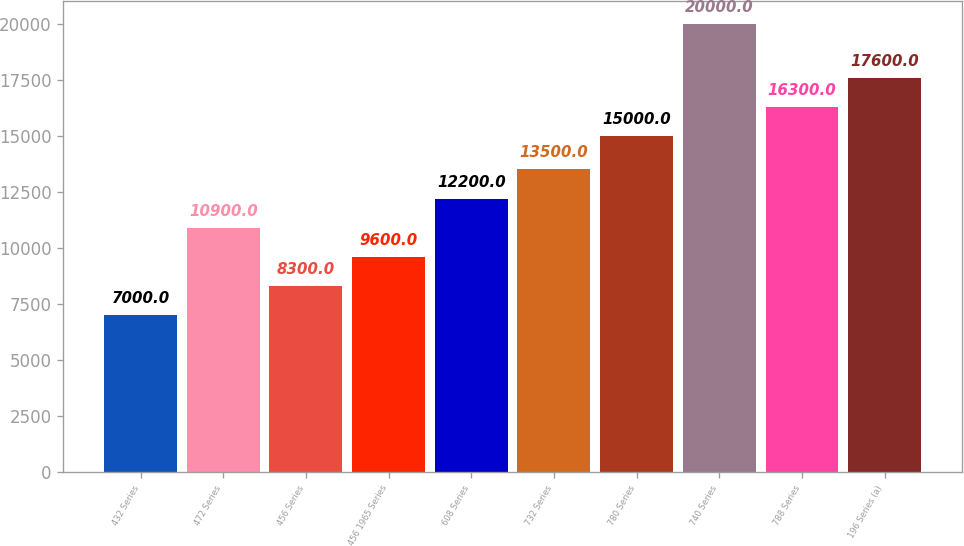Convert chart. <chart><loc_0><loc_0><loc_500><loc_500><bar_chart><fcel>432 Series<fcel>472 Series<fcel>456 Series<fcel>456 1965 Series<fcel>608 Series<fcel>732 Series<fcel>780 Series<fcel>740 Series<fcel>788 Series<fcel>196 Series (a)<nl><fcel>7000<fcel>10900<fcel>8300<fcel>9600<fcel>12200<fcel>13500<fcel>15000<fcel>20000<fcel>16300<fcel>17600<nl></chart> 